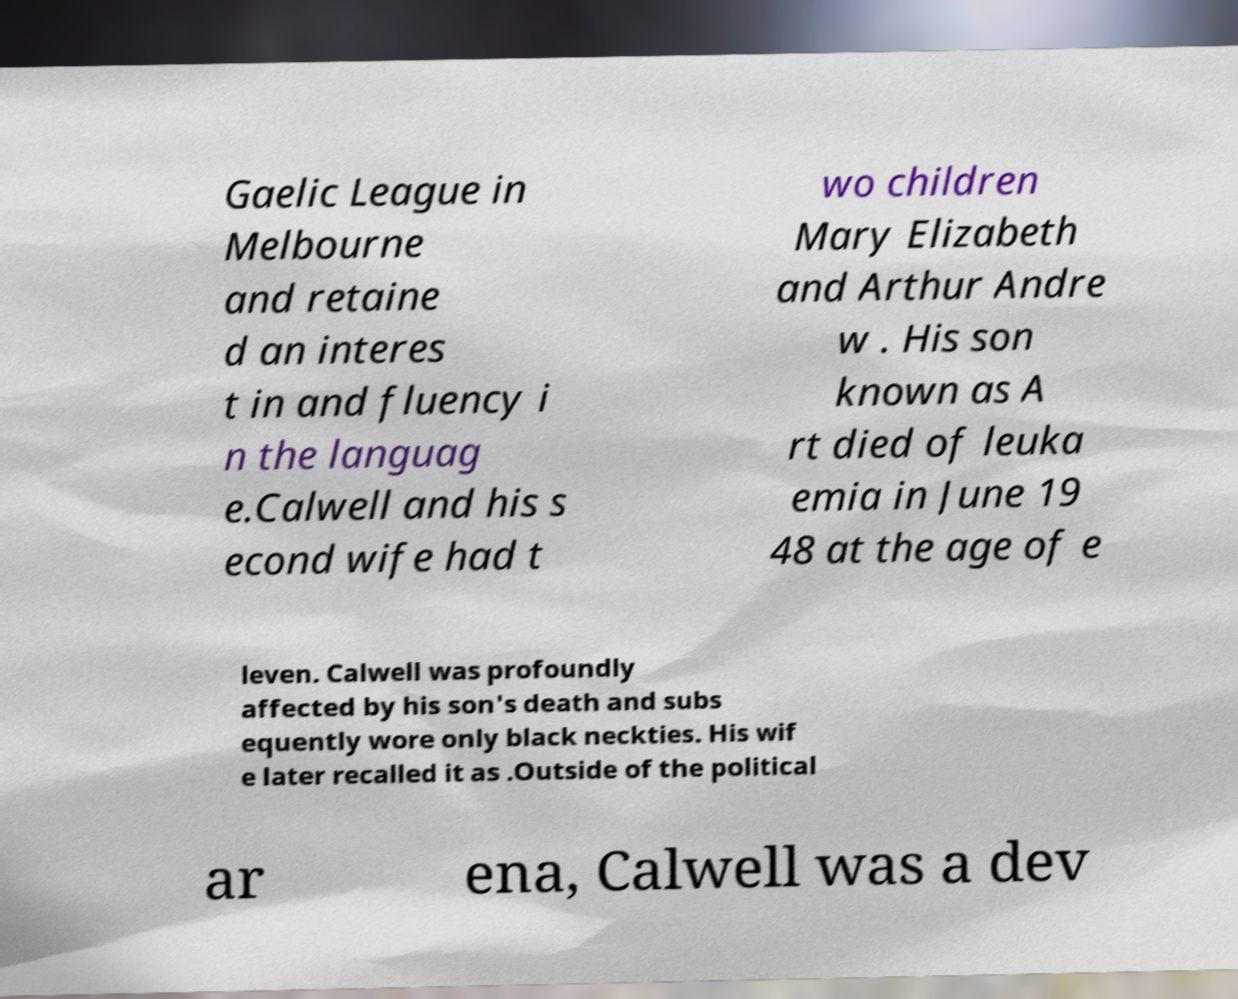Please read and relay the text visible in this image. What does it say? Gaelic League in Melbourne and retaine d an interes t in and fluency i n the languag e.Calwell and his s econd wife had t wo children Mary Elizabeth and Arthur Andre w . His son known as A rt died of leuka emia in June 19 48 at the age of e leven. Calwell was profoundly affected by his son's death and subs equently wore only black neckties. His wif e later recalled it as .Outside of the political ar ena, Calwell was a dev 